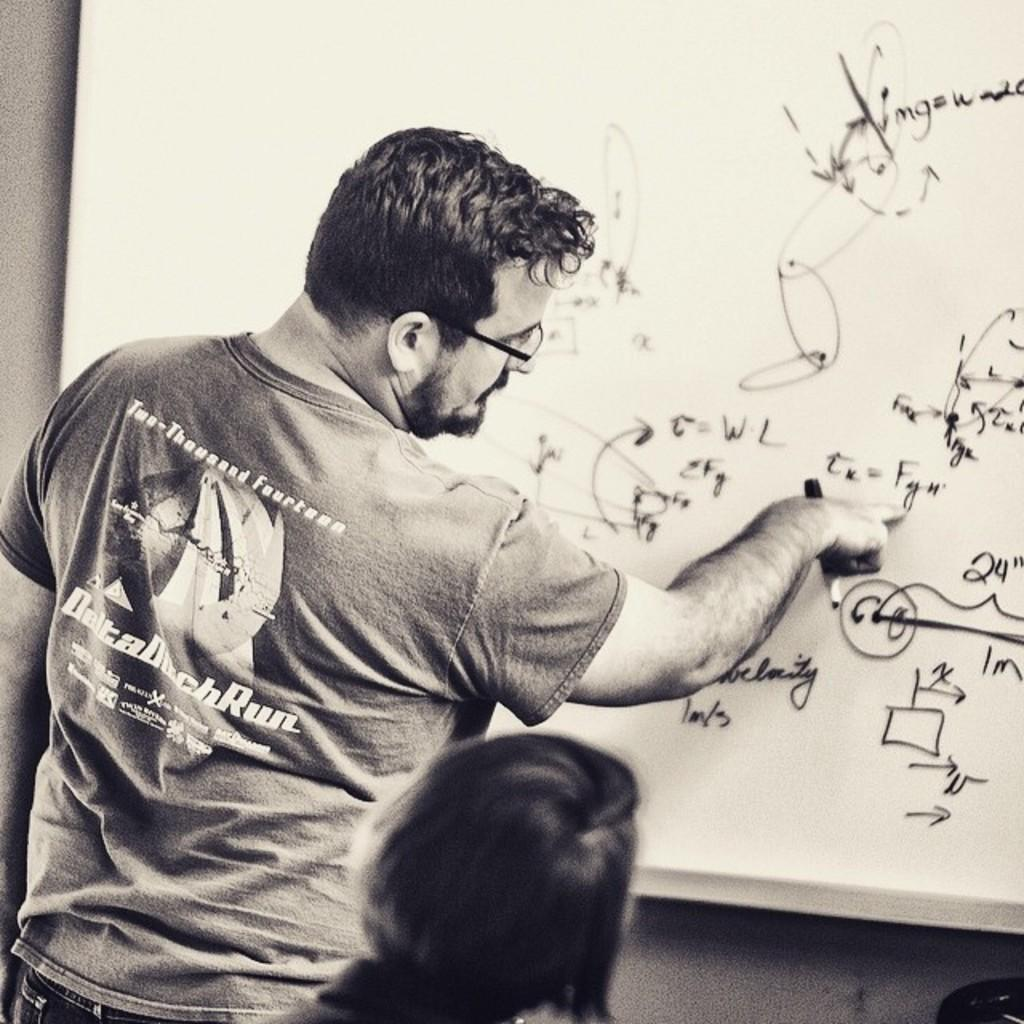<image>
Summarize the visual content of the image. A man points to the term "Fyu" in his math equation on the board. 